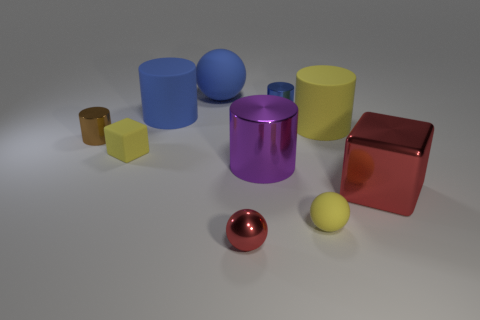How many other things are the same color as the big ball?
Provide a succinct answer. 2. There is a brown cylinder; does it have the same size as the matte sphere in front of the yellow cylinder?
Offer a terse response. Yes. There is a block that is to the right of the small yellow rubber object that is behind the big shiny cylinder; how big is it?
Provide a succinct answer. Large. What is the color of the other object that is the same shape as the big red object?
Offer a very short reply. Yellow. Do the blue shiny object and the red metal cube have the same size?
Provide a succinct answer. No. Are there an equal number of small blocks in front of the small red metal object and small purple rubber things?
Provide a succinct answer. Yes. Is there a blue rubber sphere behind the object left of the tiny block?
Your answer should be compact. Yes. There is a shiny cylinder that is behind the tiny metallic cylinder that is left of the matte ball behind the yellow ball; how big is it?
Your answer should be compact. Small. There is a sphere that is in front of the small yellow object in front of the red cube; what is it made of?
Provide a short and direct response. Metal. Is there a purple metallic object of the same shape as the big red metal object?
Offer a terse response. No. 